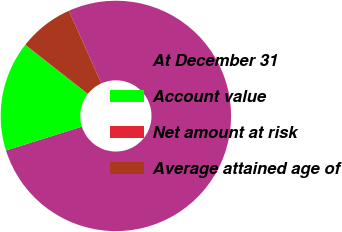<chart> <loc_0><loc_0><loc_500><loc_500><pie_chart><fcel>At December 31<fcel>Account value<fcel>Net amount at risk<fcel>Average attained age of<nl><fcel>76.84%<fcel>15.4%<fcel>0.04%<fcel>7.72%<nl></chart> 